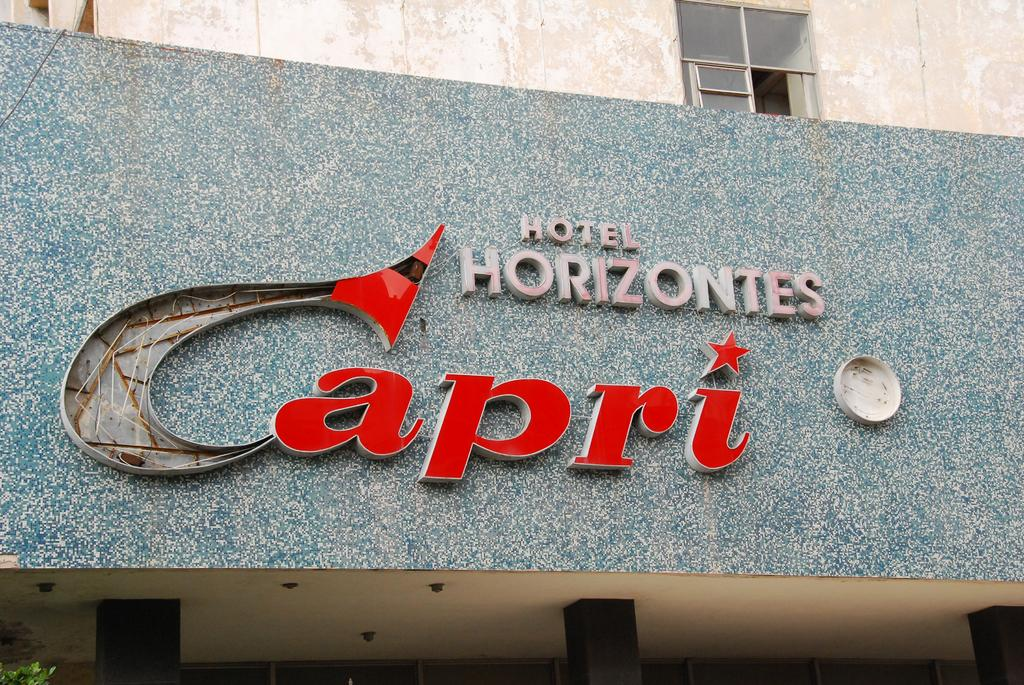<image>
Write a terse but informative summary of the picture. A damaged sign for the Hotel Horizontes Capri. 